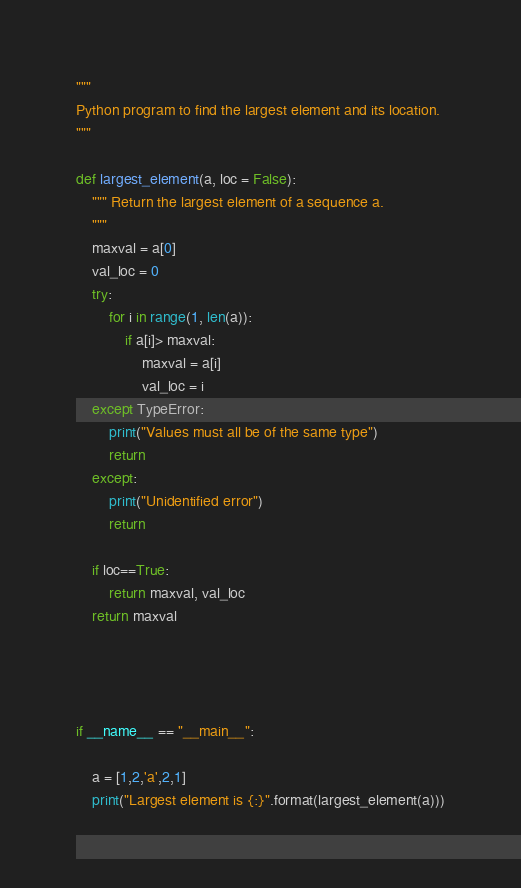<code> <loc_0><loc_0><loc_500><loc_500><_Python_>"""
Python program to find the largest element and its location.
"""

def largest_element(a, loc = False):
    """ Return the largest element of a sequence a.
    """
    maxval = a[0]
    val_loc = 0
    try:
        for i in range(1, len(a)):
            if a[i]> maxval:
                maxval = a[i]
                val_loc = i
    except TypeError:
        print("Values must all be of the same type")
        return
    except:
        print("Unidentified error")
        return

    if loc==True:
        return maxval, val_loc
    return maxval




if __name__ == "__main__":

    a = [1,2,'a',2,1]
    print("Largest element is {:}".format(largest_element(a)))
</code> 